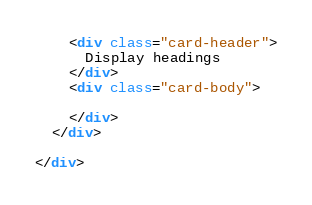<code> <loc_0><loc_0><loc_500><loc_500><_HTML_>    <div class="card-header">
      Display headings
    </div>
    <div class="card-body">

    </div>
  </div>

</div>
</code> 